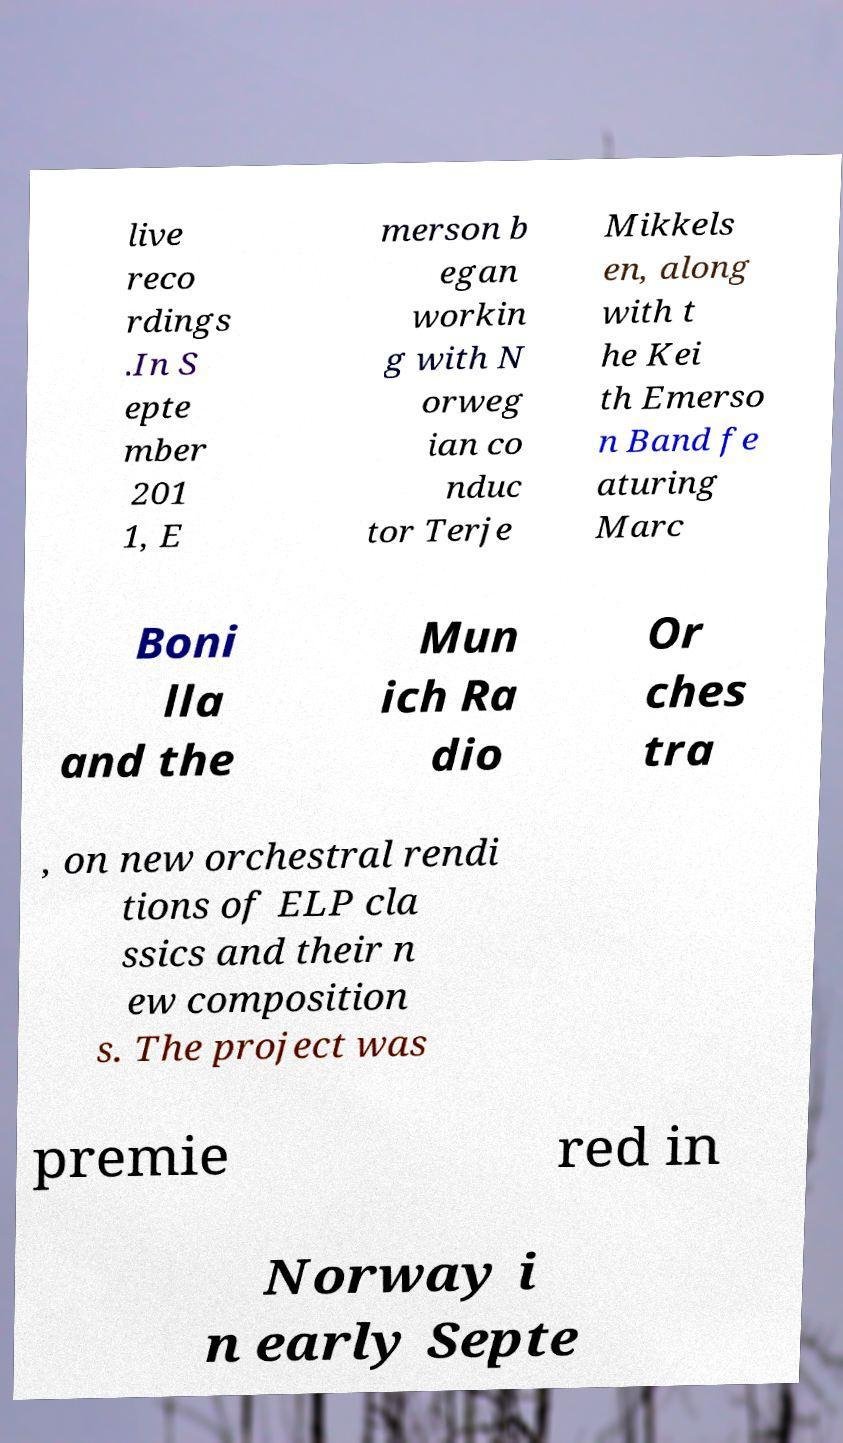There's text embedded in this image that I need extracted. Can you transcribe it verbatim? live reco rdings .In S epte mber 201 1, E merson b egan workin g with N orweg ian co nduc tor Terje Mikkels en, along with t he Kei th Emerso n Band fe aturing Marc Boni lla and the Mun ich Ra dio Or ches tra , on new orchestral rendi tions of ELP cla ssics and their n ew composition s. The project was premie red in Norway i n early Septe 